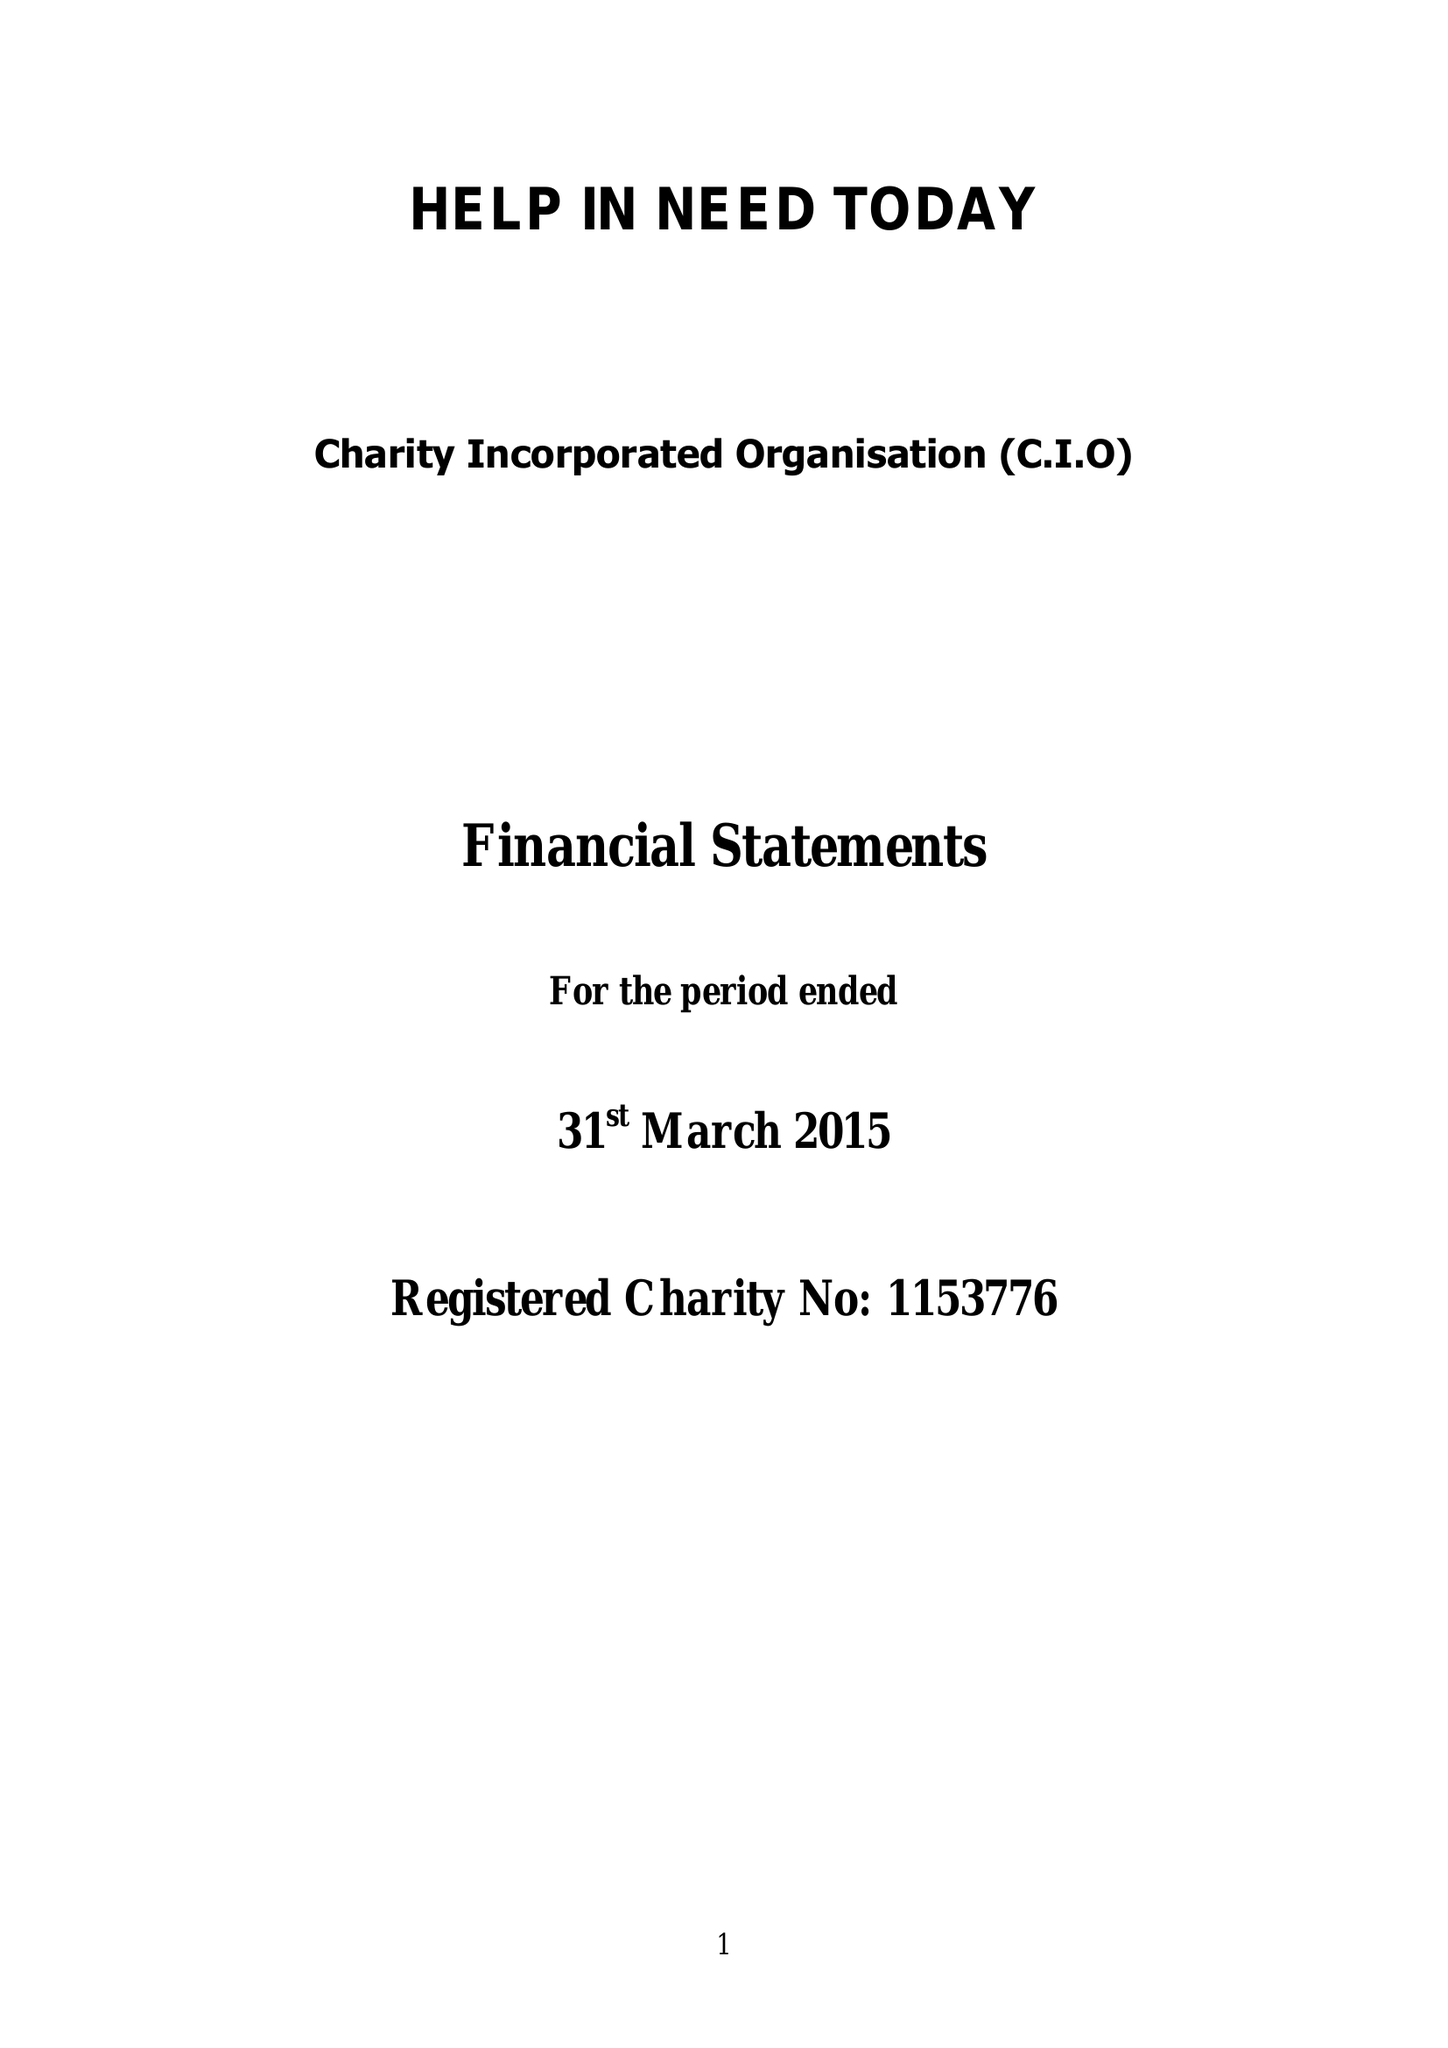What is the value for the charity_number?
Answer the question using a single word or phrase. 1153776 